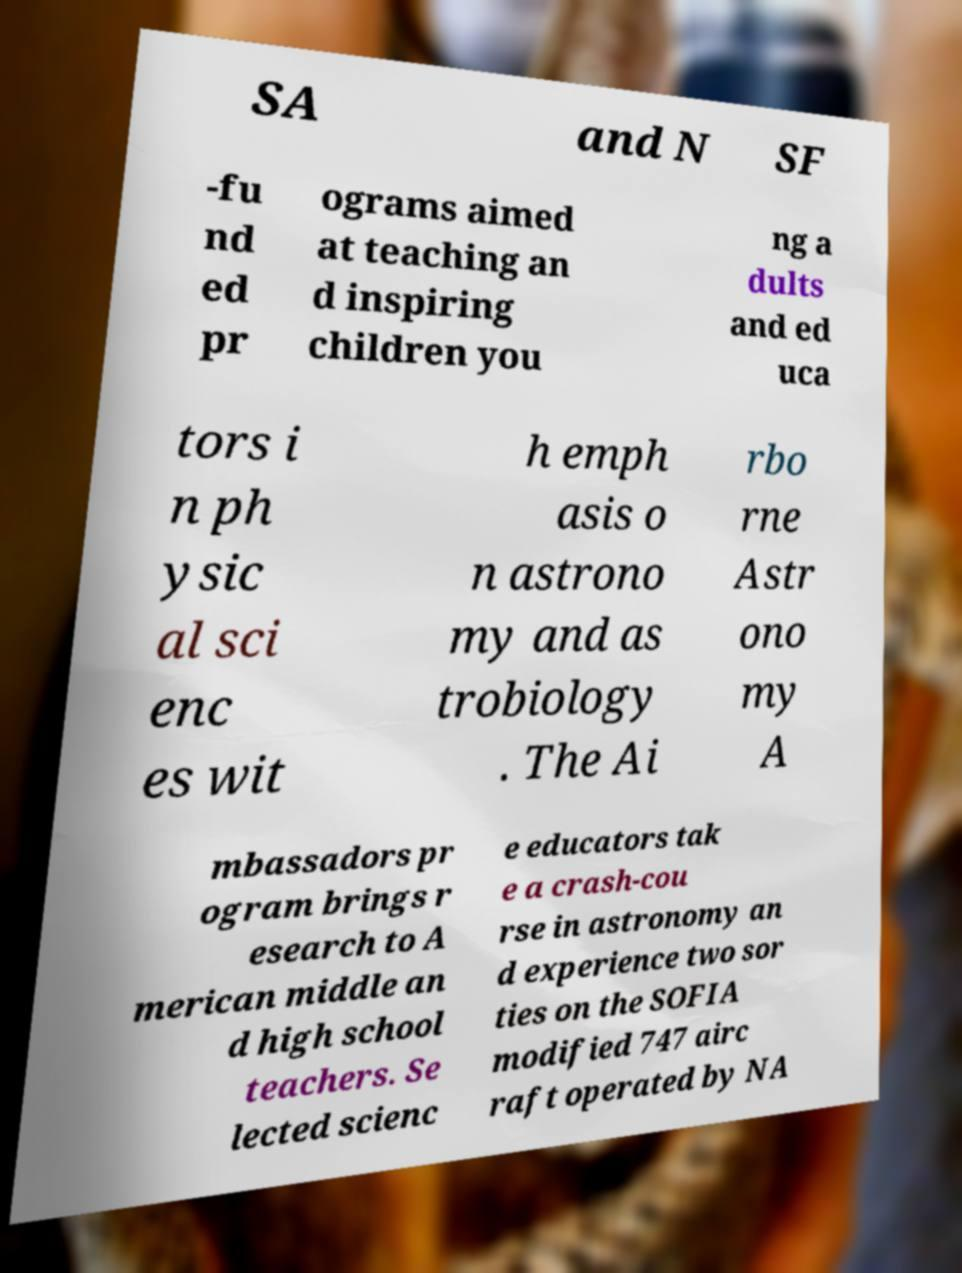Could you extract and type out the text from this image? SA and N SF -fu nd ed pr ograms aimed at teaching an d inspiring children you ng a dults and ed uca tors i n ph ysic al sci enc es wit h emph asis o n astrono my and as trobiology . The Ai rbo rne Astr ono my A mbassadors pr ogram brings r esearch to A merican middle an d high school teachers. Se lected scienc e educators tak e a crash-cou rse in astronomy an d experience two sor ties on the SOFIA modified 747 airc raft operated by NA 